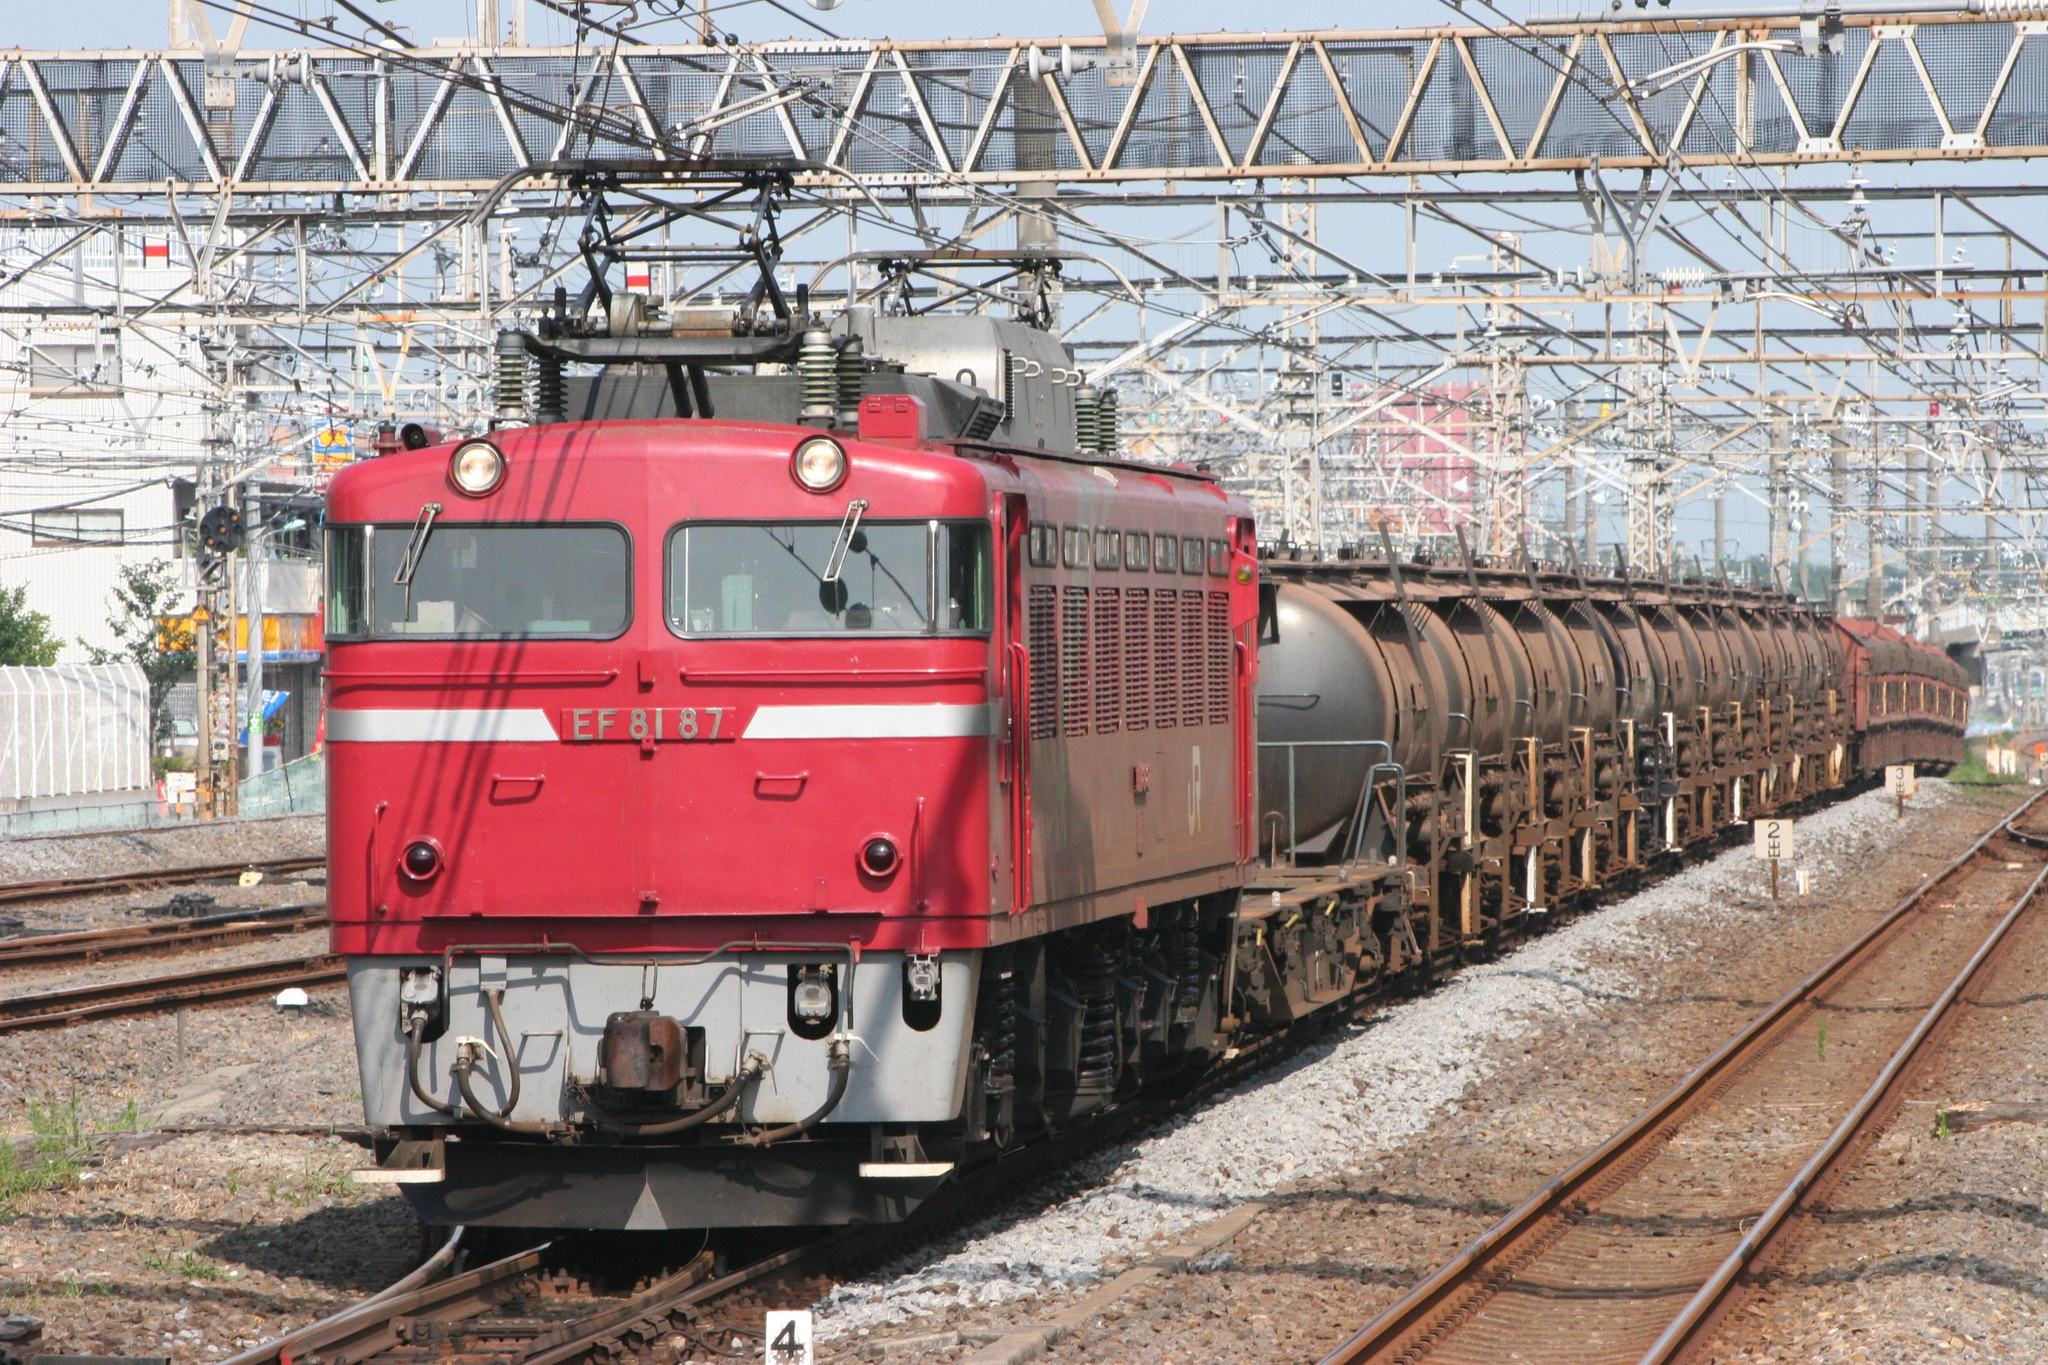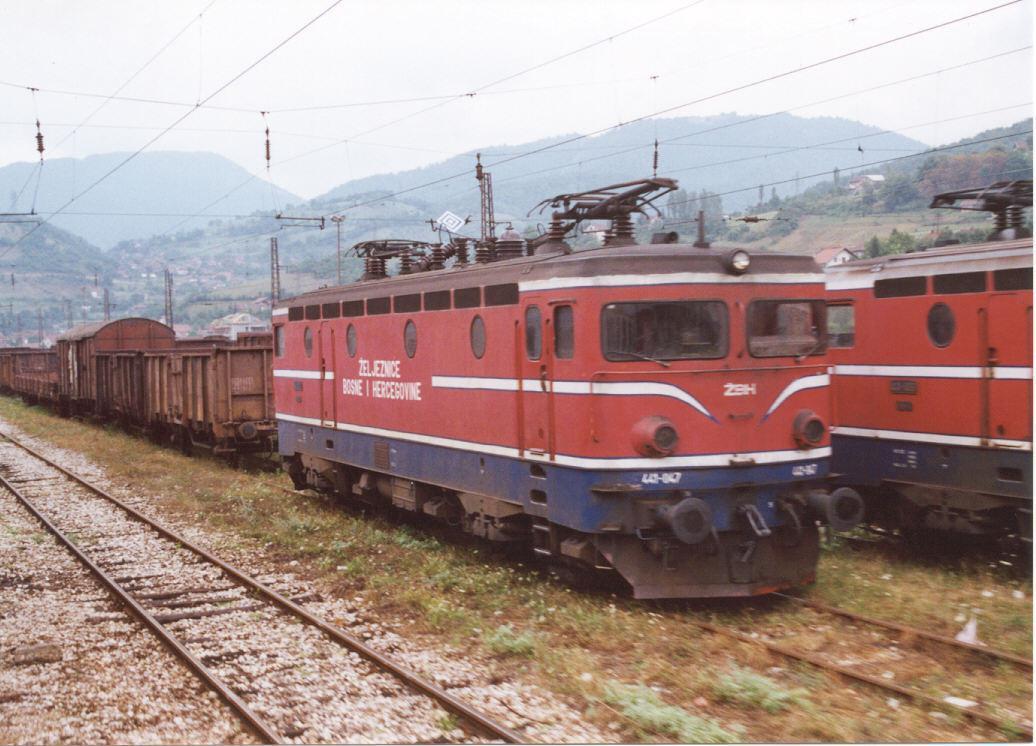The first image is the image on the left, the second image is the image on the right. Given the left and right images, does the statement "Two trains are angled so as to travel in the same direction when they move." hold true? Answer yes or no. No. The first image is the image on the left, the second image is the image on the right. Given the left and right images, does the statement "None of the trains have their headlights on and none of the them are decorated with balloons." hold true? Answer yes or no. Yes. 